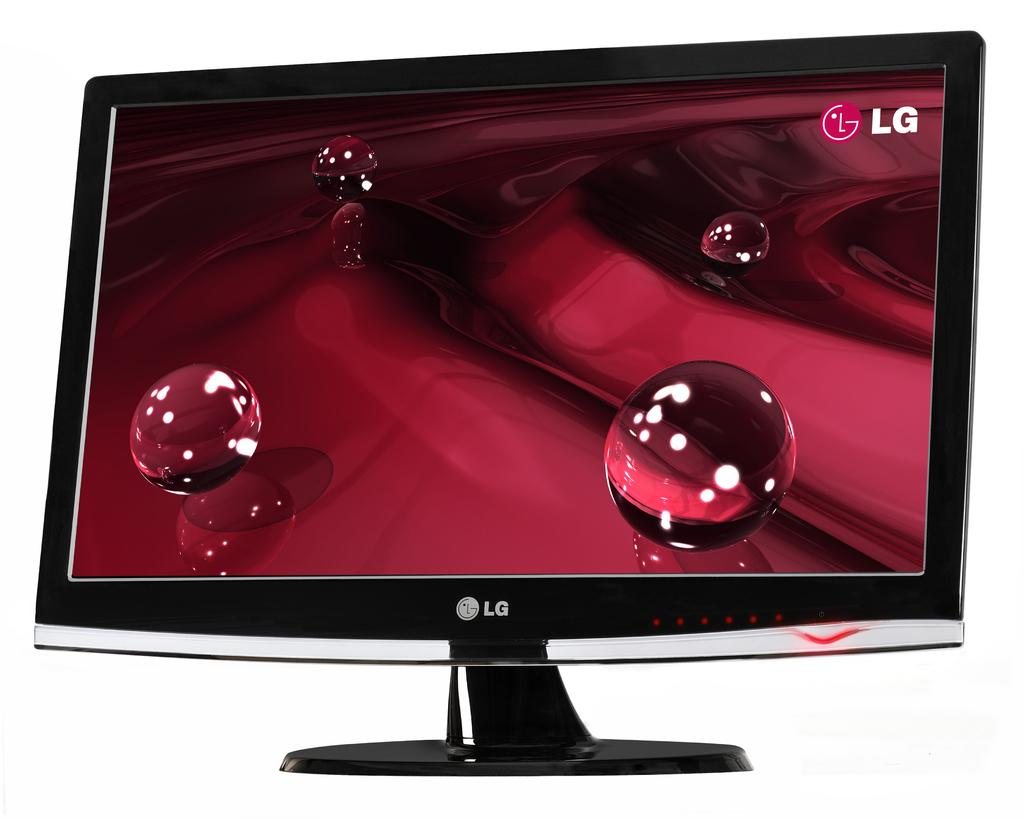<image>
Render a clear and concise summary of the photo. A black computer monitor that says LG on the front. 